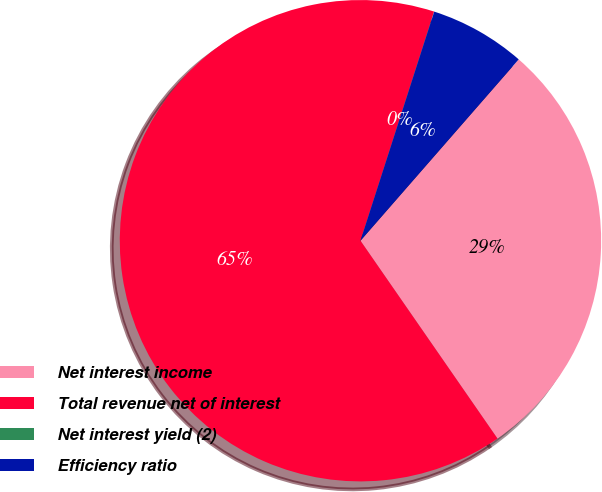<chart> <loc_0><loc_0><loc_500><loc_500><pie_chart><fcel>Net interest income<fcel>Total revenue net of interest<fcel>Net interest yield (2)<fcel>Efficiency ratio<nl><fcel>28.94%<fcel>64.59%<fcel>0.01%<fcel>6.46%<nl></chart> 